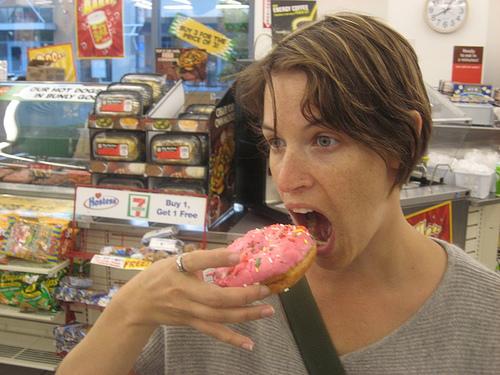Does the doughnut have sprinkles?
Answer briefly. Yes. What is she eating?
Be succinct. Donut. How many doughnuts are there?
Answer briefly. 1. Which finger has a ring?
Give a very brief answer. Index. What color is the food item she's eating?
Keep it brief. Pink. 